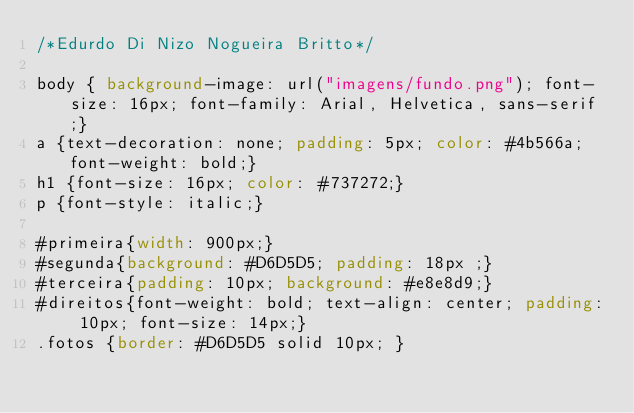Convert code to text. <code><loc_0><loc_0><loc_500><loc_500><_CSS_>/*Edurdo Di Nizo Nogueira Britto*/

body { background-image: url("imagens/fundo.png"); font-size: 16px; font-family: Arial, Helvetica, sans-serif;}
a {text-decoration: none; padding: 5px; color: #4b566a; font-weight: bold;}
h1 {font-size: 16px; color: #737272;}
p {font-style: italic;}

#primeira{width: 900px;}
#segunda{background: #D6D5D5; padding: 18px ;}
#terceira{padding: 10px; background: #e8e8d9;}
#direitos{font-weight: bold; text-align: center; padding: 10px; font-size: 14px;}
.fotos {border: #D6D5D5 solid 10px; }
</code> 